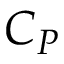<formula> <loc_0><loc_0><loc_500><loc_500>C _ { P }</formula> 